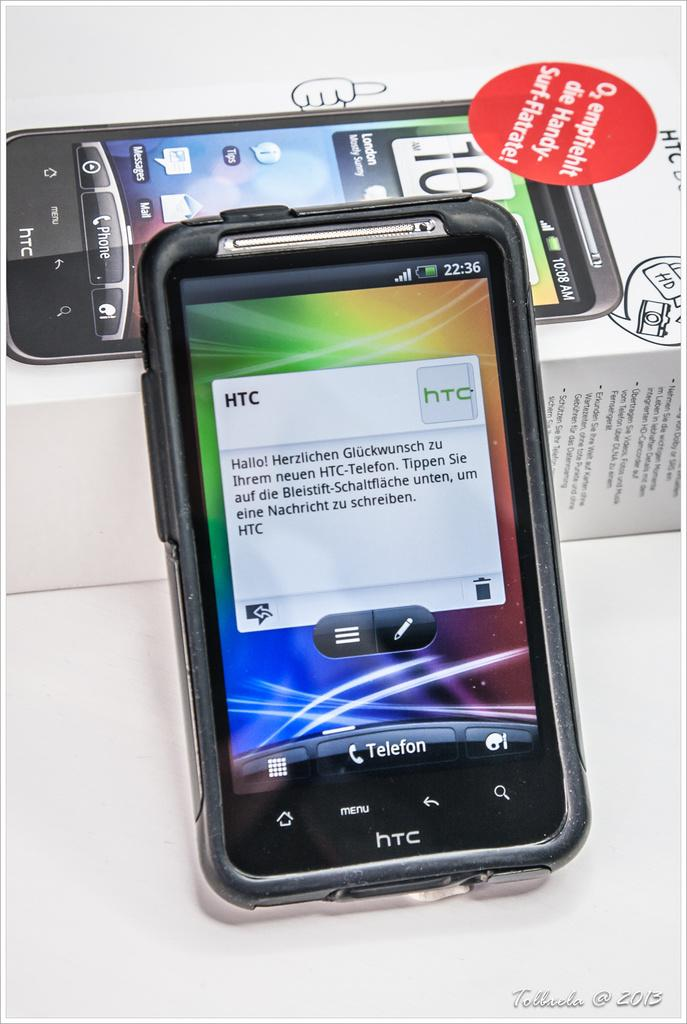<image>
Write a terse but informative summary of the picture. A HTC smartphone with German text box on the screen is leaning on its box. 